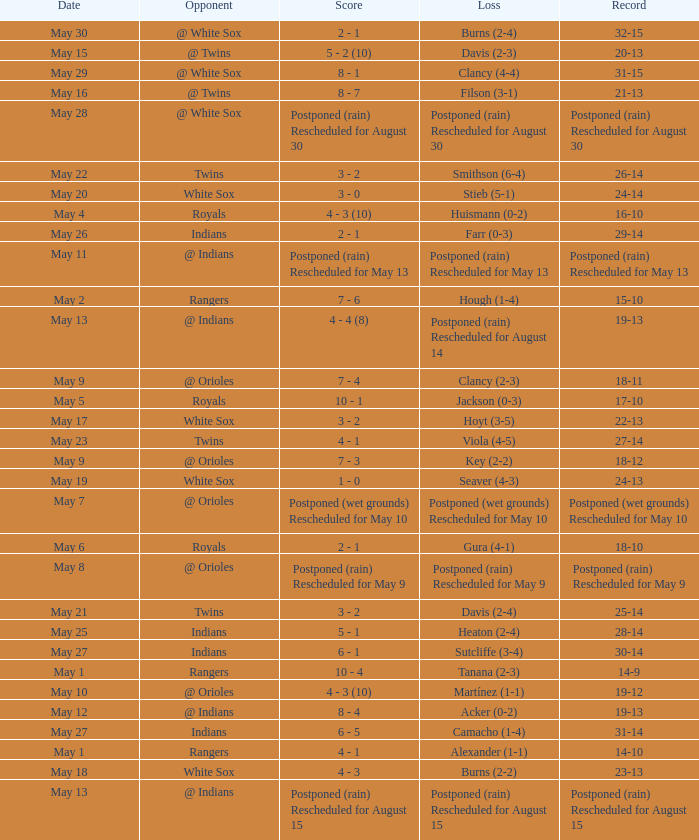What was the loss of the game when the record was 21-13? Filson (3-1). Could you parse the entire table? {'header': ['Date', 'Opponent', 'Score', 'Loss', 'Record'], 'rows': [['May 30', '@ White Sox', '2 - 1', 'Burns (2-4)', '32-15'], ['May 15', '@ Twins', '5 - 2 (10)', 'Davis (2-3)', '20-13'], ['May 29', '@ White Sox', '8 - 1', 'Clancy (4-4)', '31-15'], ['May 16', '@ Twins', '8 - 7', 'Filson (3-1)', '21-13'], ['May 28', '@ White Sox', 'Postponed (rain) Rescheduled for August 30', 'Postponed (rain) Rescheduled for August 30', 'Postponed (rain) Rescheduled for August 30'], ['May 22', 'Twins', '3 - 2', 'Smithson (6-4)', '26-14'], ['May 20', 'White Sox', '3 - 0', 'Stieb (5-1)', '24-14'], ['May 4', 'Royals', '4 - 3 (10)', 'Huismann (0-2)', '16-10'], ['May 26', 'Indians', '2 - 1', 'Farr (0-3)', '29-14'], ['May 11', '@ Indians', 'Postponed (rain) Rescheduled for May 13', 'Postponed (rain) Rescheduled for May 13', 'Postponed (rain) Rescheduled for May 13'], ['May 2', 'Rangers', '7 - 6', 'Hough (1-4)', '15-10'], ['May 13', '@ Indians', '4 - 4 (8)', 'Postponed (rain) Rescheduled for August 14', '19-13'], ['May 9', '@ Orioles', '7 - 4', 'Clancy (2-3)', '18-11'], ['May 5', 'Royals', '10 - 1', 'Jackson (0-3)', '17-10'], ['May 17', 'White Sox', '3 - 2', 'Hoyt (3-5)', '22-13'], ['May 23', 'Twins', '4 - 1', 'Viola (4-5)', '27-14'], ['May 9', '@ Orioles', '7 - 3', 'Key (2-2)', '18-12'], ['May 19', 'White Sox', '1 - 0', 'Seaver (4-3)', '24-13'], ['May 7', '@ Orioles', 'Postponed (wet grounds) Rescheduled for May 10', 'Postponed (wet grounds) Rescheduled for May 10', 'Postponed (wet grounds) Rescheduled for May 10'], ['May 6', 'Royals', '2 - 1', 'Gura (4-1)', '18-10'], ['May 8', '@ Orioles', 'Postponed (rain) Rescheduled for May 9', 'Postponed (rain) Rescheduled for May 9', 'Postponed (rain) Rescheduled for May 9'], ['May 21', 'Twins', '3 - 2', 'Davis (2-4)', '25-14'], ['May 25', 'Indians', '5 - 1', 'Heaton (2-4)', '28-14'], ['May 27', 'Indians', '6 - 1', 'Sutcliffe (3-4)', '30-14'], ['May 1', 'Rangers', '10 - 4', 'Tanana (2-3)', '14-9'], ['May 10', '@ Orioles', '4 - 3 (10)', 'Martínez (1-1)', '19-12'], ['May 12', '@ Indians', '8 - 4', 'Acker (0-2)', '19-13'], ['May 27', 'Indians', '6 - 5', 'Camacho (1-4)', '31-14'], ['May 1', 'Rangers', '4 - 1', 'Alexander (1-1)', '14-10'], ['May 18', 'White Sox', '4 - 3', 'Burns (2-2)', '23-13'], ['May 13', '@ Indians', 'Postponed (rain) Rescheduled for August 15', 'Postponed (rain) Rescheduled for August 15', 'Postponed (rain) Rescheduled for August 15']]} 